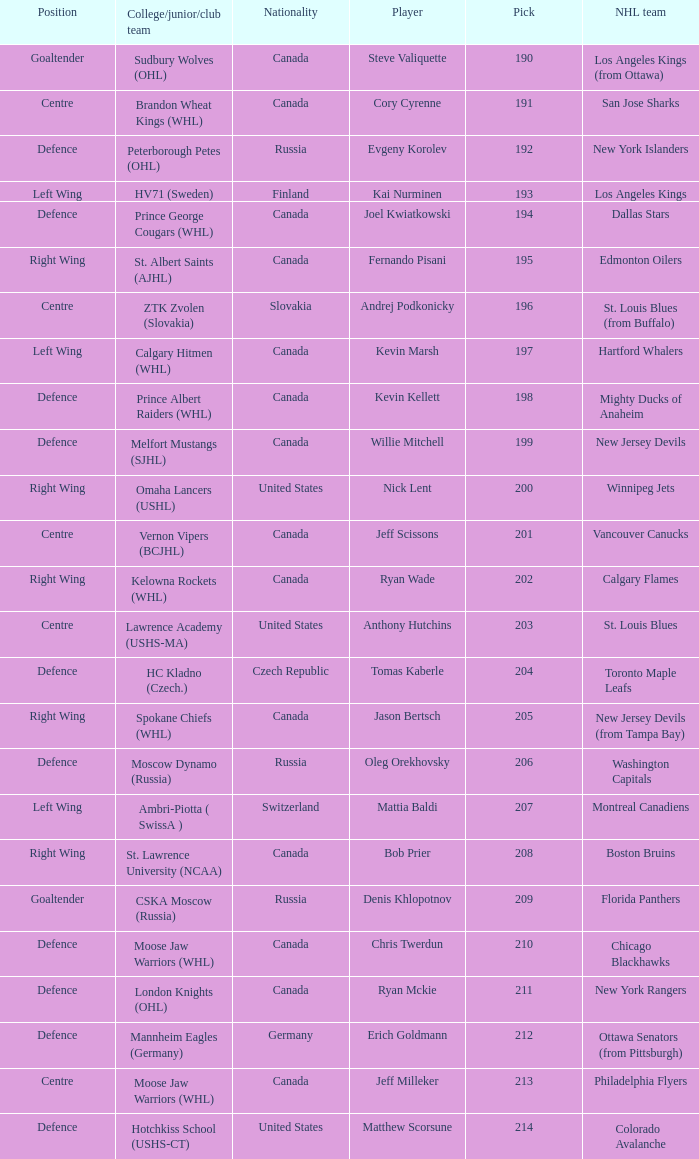Name the number of nationalities for ryan mckie 1.0. Give me the full table as a dictionary. {'header': ['Position', 'College/junior/club team', 'Nationality', 'Player', 'Pick', 'NHL team'], 'rows': [['Goaltender', 'Sudbury Wolves (OHL)', 'Canada', 'Steve Valiquette', '190', 'Los Angeles Kings (from Ottawa)'], ['Centre', 'Brandon Wheat Kings (WHL)', 'Canada', 'Cory Cyrenne', '191', 'San Jose Sharks'], ['Defence', 'Peterborough Petes (OHL)', 'Russia', 'Evgeny Korolev', '192', 'New York Islanders'], ['Left Wing', 'HV71 (Sweden)', 'Finland', 'Kai Nurminen', '193', 'Los Angeles Kings'], ['Defence', 'Prince George Cougars (WHL)', 'Canada', 'Joel Kwiatkowski', '194', 'Dallas Stars'], ['Right Wing', 'St. Albert Saints (AJHL)', 'Canada', 'Fernando Pisani', '195', 'Edmonton Oilers'], ['Centre', 'ZTK Zvolen (Slovakia)', 'Slovakia', 'Andrej Podkonicky', '196', 'St. Louis Blues (from Buffalo)'], ['Left Wing', 'Calgary Hitmen (WHL)', 'Canada', 'Kevin Marsh', '197', 'Hartford Whalers'], ['Defence', 'Prince Albert Raiders (WHL)', 'Canada', 'Kevin Kellett', '198', 'Mighty Ducks of Anaheim'], ['Defence', 'Melfort Mustangs (SJHL)', 'Canada', 'Willie Mitchell', '199', 'New Jersey Devils'], ['Right Wing', 'Omaha Lancers (USHL)', 'United States', 'Nick Lent', '200', 'Winnipeg Jets'], ['Centre', 'Vernon Vipers (BCJHL)', 'Canada', 'Jeff Scissons', '201', 'Vancouver Canucks'], ['Right Wing', 'Kelowna Rockets (WHL)', 'Canada', 'Ryan Wade', '202', 'Calgary Flames'], ['Centre', 'Lawrence Academy (USHS-MA)', 'United States', 'Anthony Hutchins', '203', 'St. Louis Blues'], ['Defence', 'HC Kladno (Czech.)', 'Czech Republic', 'Tomas Kaberle', '204', 'Toronto Maple Leafs'], ['Right Wing', 'Spokane Chiefs (WHL)', 'Canada', 'Jason Bertsch', '205', 'New Jersey Devils (from Tampa Bay)'], ['Defence', 'Moscow Dynamo (Russia)', 'Russia', 'Oleg Orekhovsky', '206', 'Washington Capitals'], ['Left Wing', 'Ambri-Piotta ( SwissA )', 'Switzerland', 'Mattia Baldi', '207', 'Montreal Canadiens'], ['Right Wing', 'St. Lawrence University (NCAA)', 'Canada', 'Bob Prier', '208', 'Boston Bruins'], ['Goaltender', 'CSKA Moscow (Russia)', 'Russia', 'Denis Khlopotnov', '209', 'Florida Panthers'], ['Defence', 'Moose Jaw Warriors (WHL)', 'Canada', 'Chris Twerdun', '210', 'Chicago Blackhawks'], ['Defence', 'London Knights (OHL)', 'Canada', 'Ryan Mckie', '211', 'New York Rangers'], ['Defence', 'Mannheim Eagles (Germany)', 'Germany', 'Erich Goldmann', '212', 'Ottawa Senators (from Pittsburgh)'], ['Centre', 'Moose Jaw Warriors (WHL)', 'Canada', 'Jeff Milleker', '213', 'Philadelphia Flyers'], ['Defence', 'Hotchkiss School (USHS-CT)', 'United States', 'Matthew Scorsune', '214', 'Colorado Avalanche']]} 